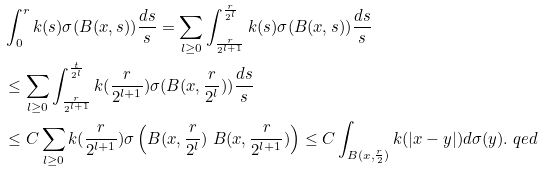<formula> <loc_0><loc_0><loc_500><loc_500>& \int _ { 0 } ^ { r } k ( s ) \sigma ( B ( x , s ) ) \frac { d s } { s } = \sum _ { l \geq 0 } \int _ { \frac { r } { 2 ^ { l + 1 } } } ^ { \frac { r } { 2 ^ { l } } } k ( s ) \sigma ( B ( x , s ) ) \frac { d s } { s } \\ & \leq \sum _ { l \geq 0 } \int _ { \frac { r } { 2 ^ { l + 1 } } } ^ { \frac { t } { 2 ^ { l } } } k ( \frac { r } { 2 ^ { l + 1 } } ) \sigma ( B ( x , \frac { r } { 2 ^ { l } } ) ) \frac { d s } { s } \\ & \leq C \sum _ { l \geq 0 } k ( \frac { r } { 2 ^ { l + 1 } } ) \sigma \left ( B ( x , \frac { r } { 2 ^ { l } } ) \ B ( x , \frac { r } { 2 ^ { l + 1 } } ) \right ) \leq C \int _ { B ( x , \frac { r } 2 ) } k ( | x - y | ) d \sigma ( y ) . \ q e d</formula> 